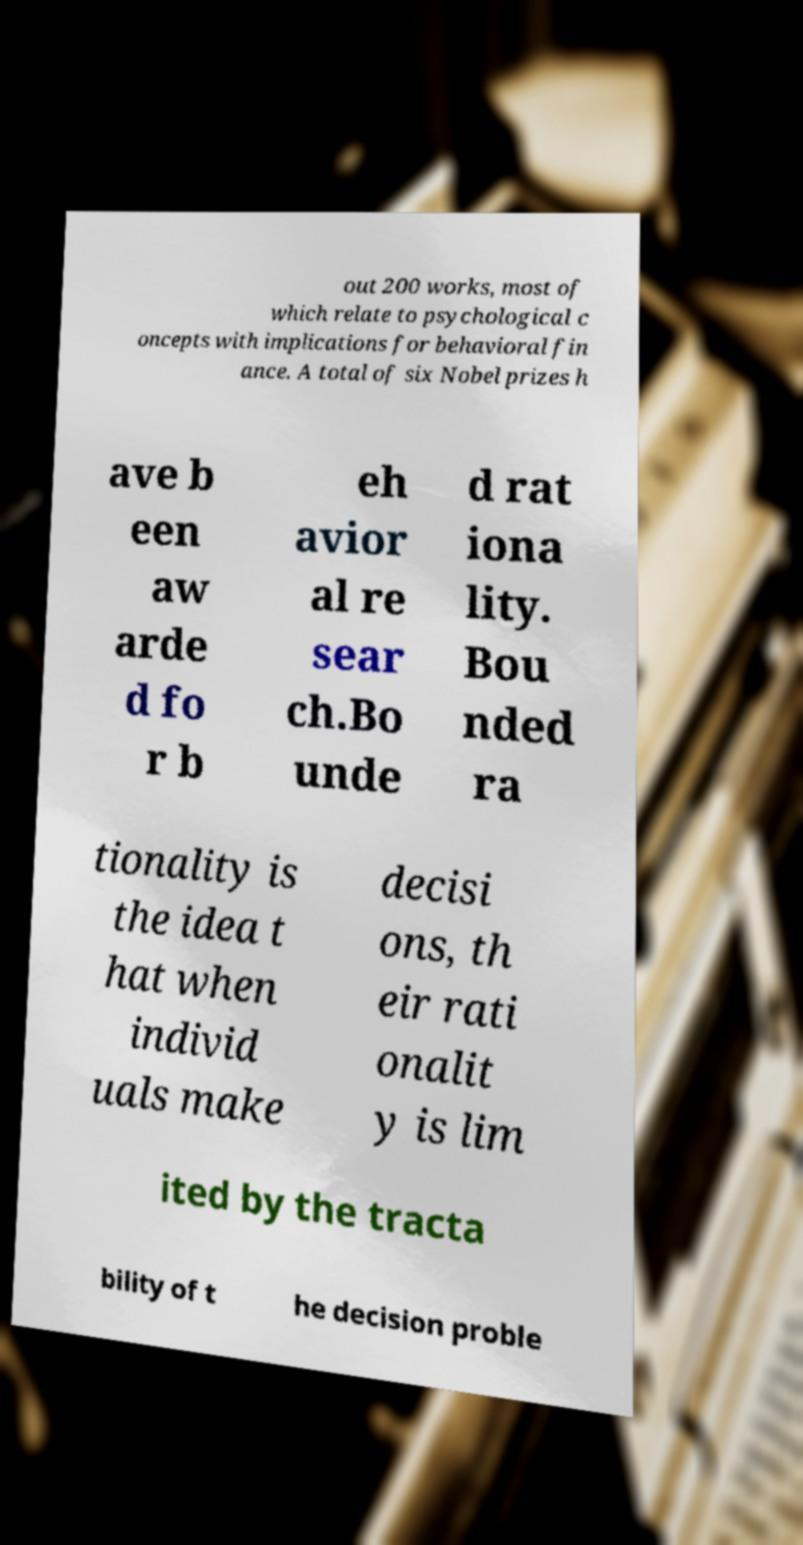What messages or text are displayed in this image? I need them in a readable, typed format. out 200 works, most of which relate to psychological c oncepts with implications for behavioral fin ance. A total of six Nobel prizes h ave b een aw arde d fo r b eh avior al re sear ch.Bo unde d rat iona lity. Bou nded ra tionality is the idea t hat when individ uals make decisi ons, th eir rati onalit y is lim ited by the tracta bility of t he decision proble 